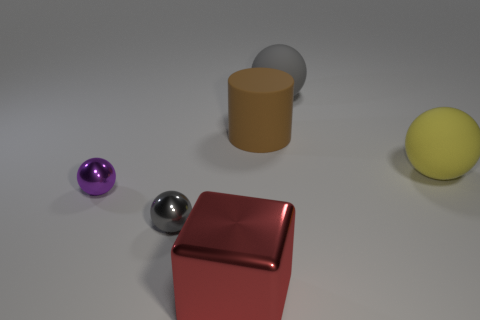What number of blue things are either large objects or spheres?
Offer a terse response. 0. There is a gray ball on the right side of the small metal object that is right of the small thing that is to the left of the tiny gray shiny object; what is its size?
Offer a terse response. Large. What size is the yellow thing that is the same shape as the tiny gray metallic thing?
Provide a short and direct response. Large. How many large objects are either gray rubber things or yellow metal cylinders?
Your answer should be very brief. 1. Is the object that is on the left side of the gray metallic ball made of the same material as the gray sphere that is behind the tiny purple metal ball?
Offer a very short reply. No. What material is the gray ball in front of the gray rubber sphere?
Keep it short and to the point. Metal. What number of metallic objects are red objects or small yellow cylinders?
Provide a succinct answer. 1. There is a large object to the right of the gray ball behind the large cylinder; what color is it?
Ensure brevity in your answer.  Yellow. Are the block and the gray sphere that is to the left of the large red block made of the same material?
Make the answer very short. Yes. The thing that is right of the gray ball that is right of the gray thing that is left of the metallic block is what color?
Provide a short and direct response. Yellow. 